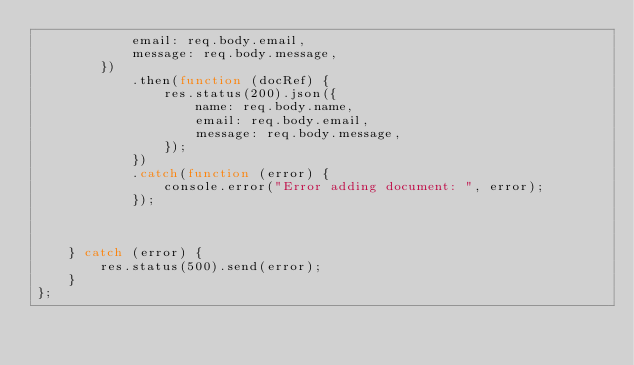Convert code to text. <code><loc_0><loc_0><loc_500><loc_500><_TypeScript_>            email: req.body.email,
            message: req.body.message,
        })
            .then(function (docRef) {
                res.status(200).json({
                    name: req.body.name,
                    email: req.body.email,
                    message: req.body.message,
                });
            })
            .catch(function (error) {
                console.error("Error adding document: ", error);
            });



    } catch (error) {
        res.status(500).send(error);
    }
};
</code> 